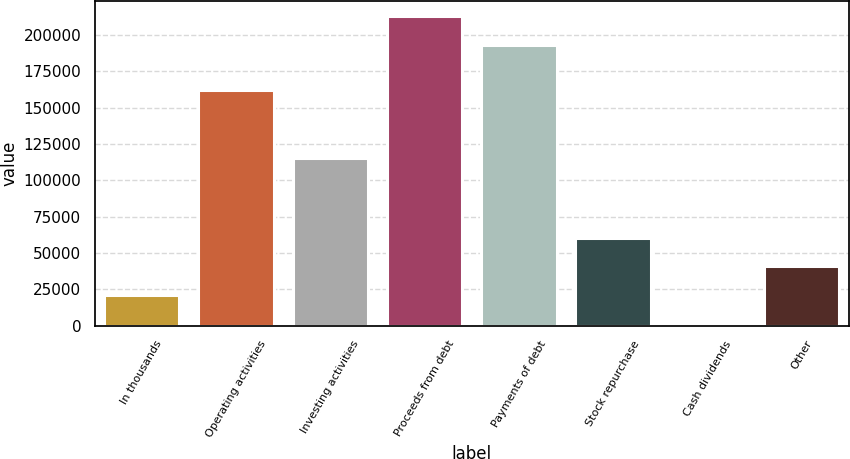<chart> <loc_0><loc_0><loc_500><loc_500><bar_chart><fcel>In thousands<fcel>Operating activities<fcel>Investing activities<fcel>Proceeds from debt<fcel>Payments of debt<fcel>Stock repurchase<fcel>Cash dividends<fcel>Other<nl><fcel>21475.3<fcel>162300<fcel>115221<fcel>212882<fcel>193324<fcel>60591.9<fcel>1917<fcel>41033.6<nl></chart> 